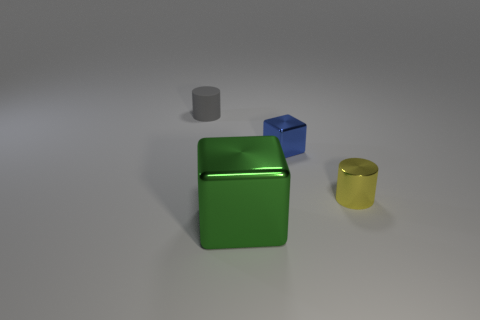What might be the purpose of these objects in the image? These objects, given their simple geometric shapes and uniform colors, could serve as props in a visual arts project, teaching tools for educational purposes in geometry, or elements in a 3D modeling software tutorial. 